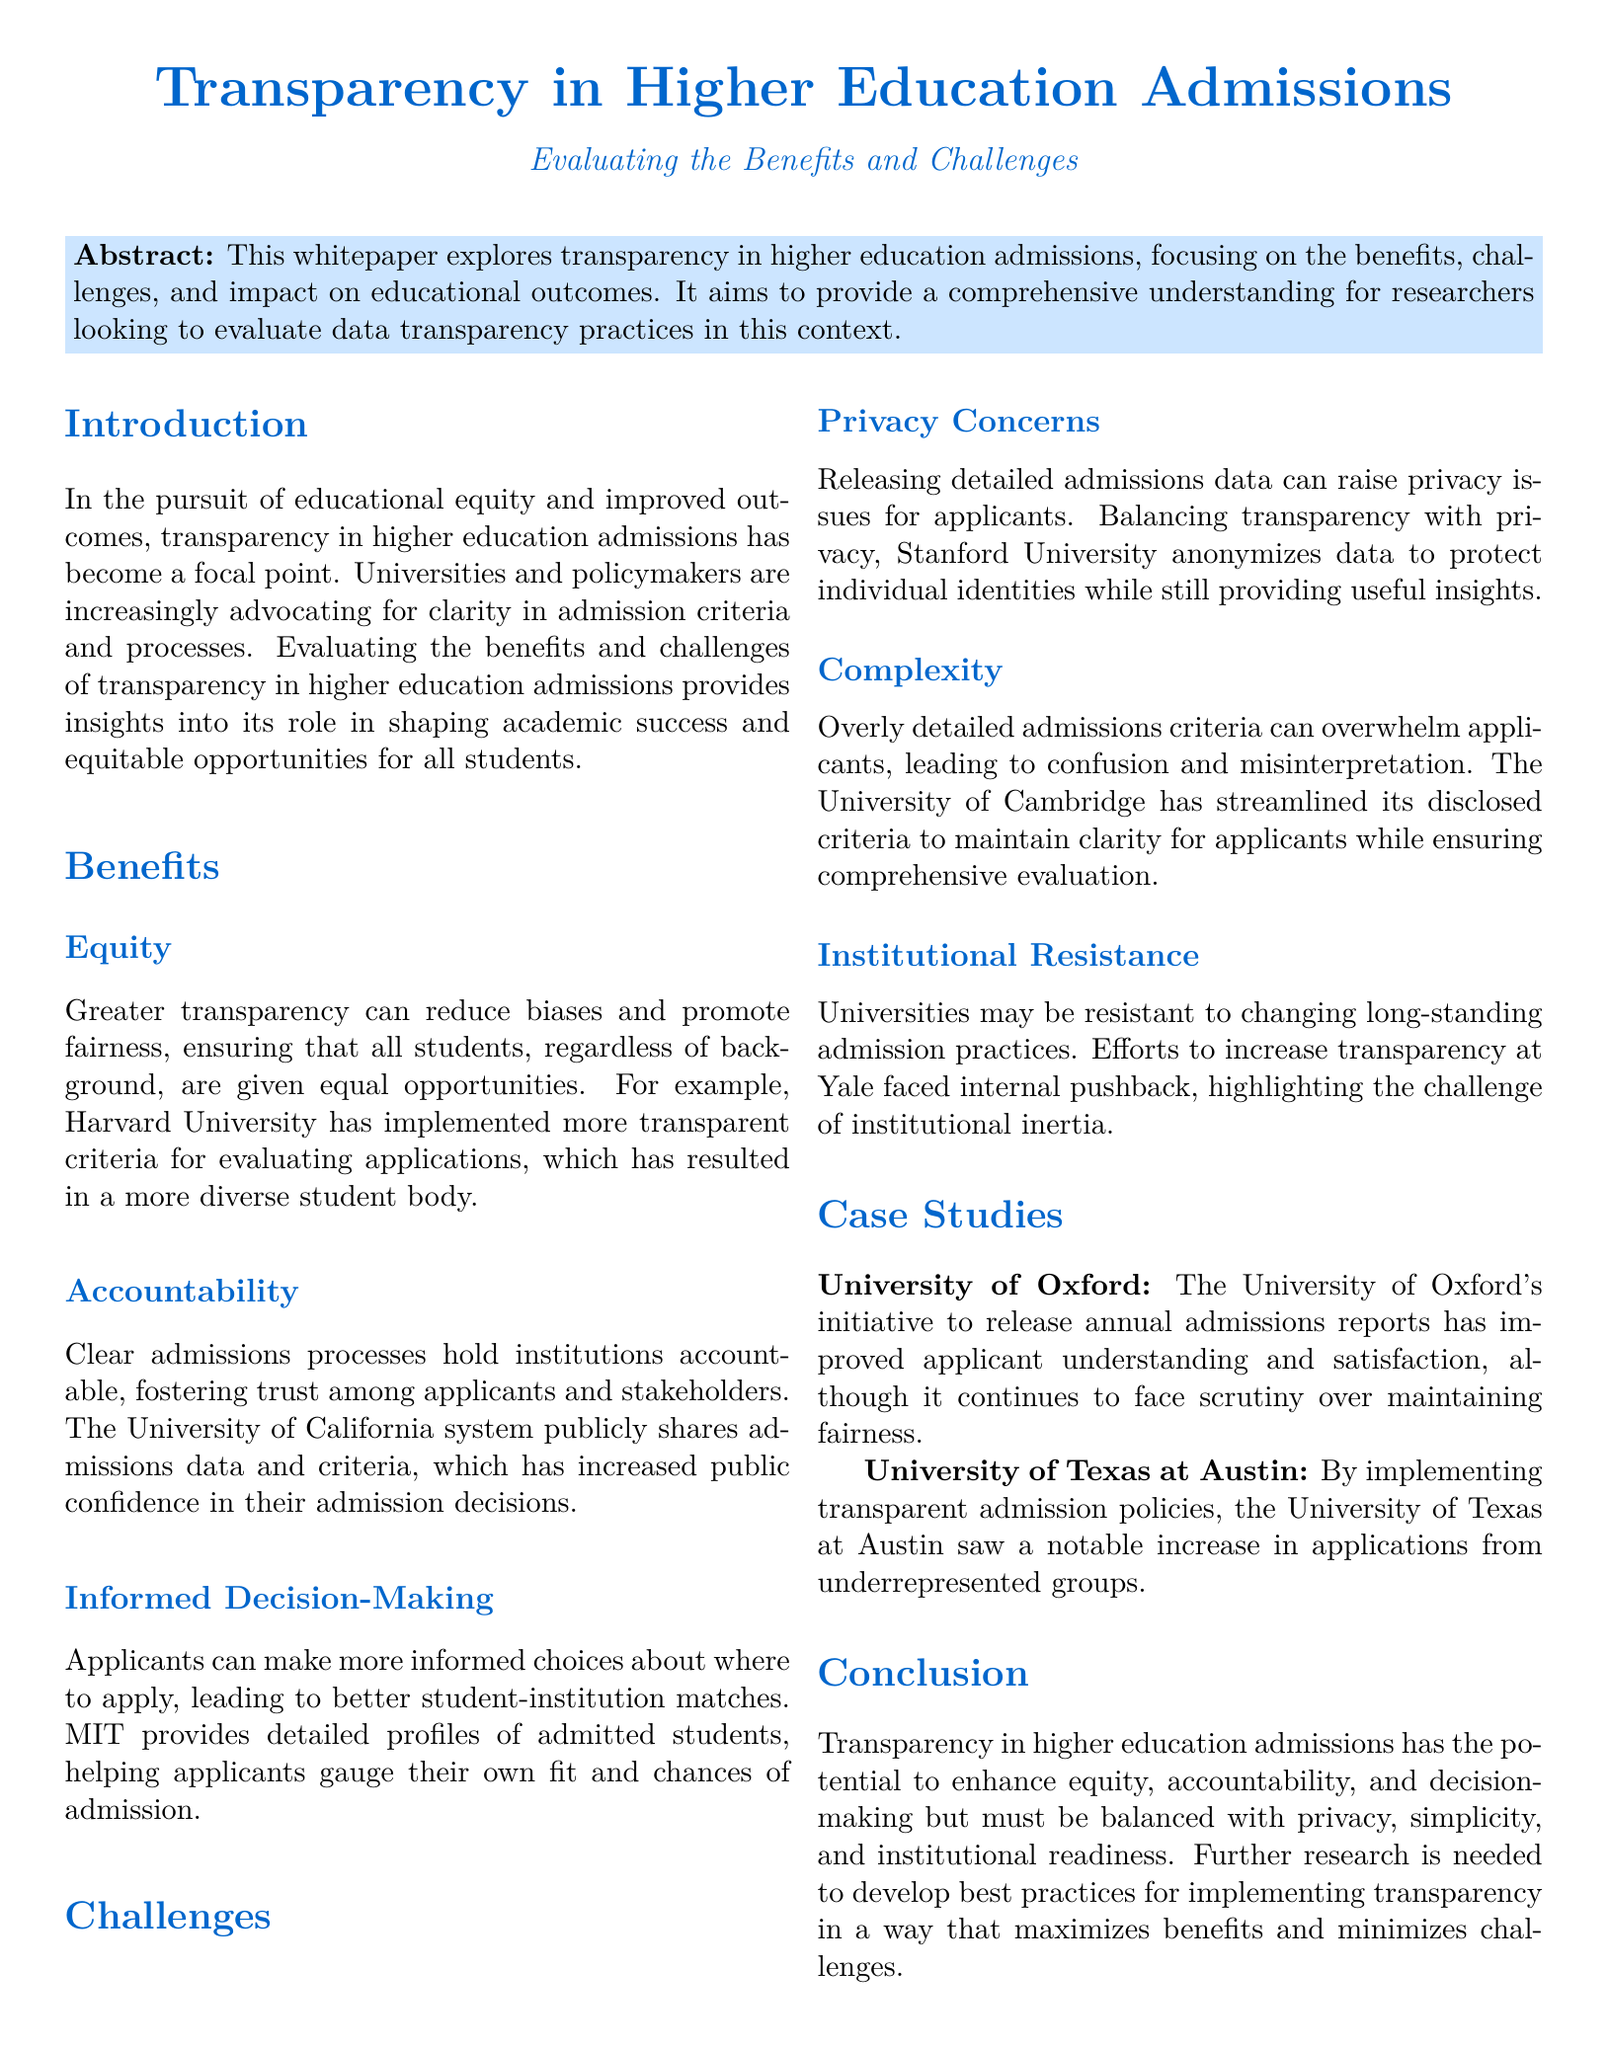What is the title of the whitepaper? The title of the whitepaper is stated prominently at the beginning of the document.
Answer: Transparency in Higher Education Admissions What university implemented more transparent criteria for evaluating applications? The document mentions Harvard University as an example of implementing transparent evaluation criteria.
Answer: Harvard University What challenge is associated with releasing detailed admissions data? The document highlights privacy concerns as a significant challenge related to detailed admissions data.
Answer: Privacy concerns Which university saw a notable increase in applications from underrepresented groups? The University of Texas at Austin is noted for this outcome due to implementing transparent admission policies.
Answer: University of Texas at Austin What is one benefit of transparency mentioned in the document? The benefits section outlines equity as a key advantage of transparency in admissions.
Answer: Equity What initiative did the University of Oxford undertake regarding admissions? The document states that the University of Oxford's initiative involved releasing annual admissions reports.
Answer: Releasing annual admissions reports What is cited as a resistance to increasing transparency in admissions? The document discusses institutional resistance as a challenge that universities face when increasing transparency.
Answer: Institutional resistance What is a recommendation for future research? The conclusion suggests that further research is needed to develop best practices in implementing transparency.
Answer: Developing best practices 